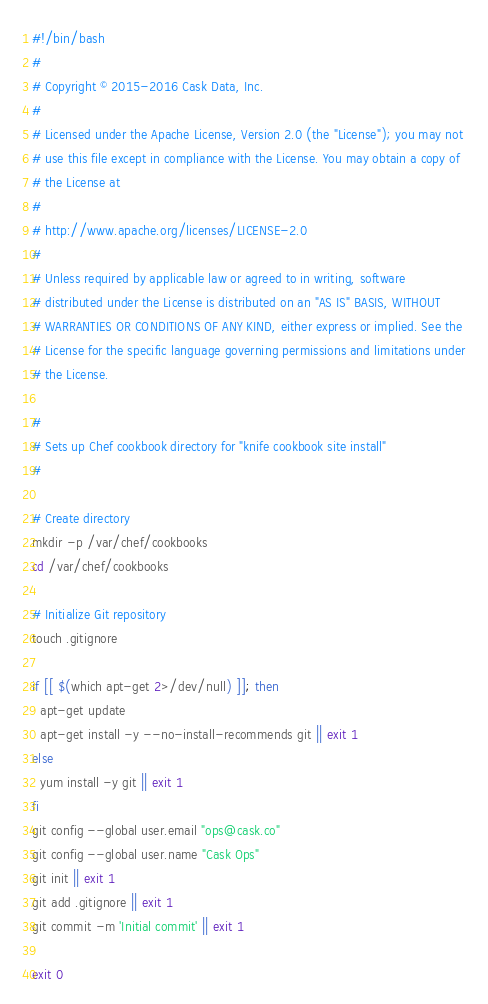Convert code to text. <code><loc_0><loc_0><loc_500><loc_500><_Bash_>#!/bin/bash
#
# Copyright © 2015-2016 Cask Data, Inc.
#
# Licensed under the Apache License, Version 2.0 (the "License"); you may not
# use this file except in compliance with the License. You may obtain a copy of
# the License at
#
# http://www.apache.org/licenses/LICENSE-2.0
#
# Unless required by applicable law or agreed to in writing, software
# distributed under the License is distributed on an "AS IS" BASIS, WITHOUT
# WARRANTIES OR CONDITIONS OF ANY KIND, either express or implied. See the
# License for the specific language governing permissions and limitations under
# the License.

#
# Sets up Chef cookbook directory for "knife cookbook site install"
#

# Create directory
mkdir -p /var/chef/cookbooks
cd /var/chef/cookbooks

# Initialize Git repository
touch .gitignore

if [[ $(which apt-get 2>/dev/null) ]]; then
  apt-get update
  apt-get install -y --no-install-recommends git || exit 1
else
  yum install -y git || exit 1
fi
git config --global user.email "ops@cask.co"
git config --global user.name "Cask Ops"
git init || exit 1
git add .gitignore || exit 1
git commit -m 'Initial commit' || exit 1

exit 0
</code> 